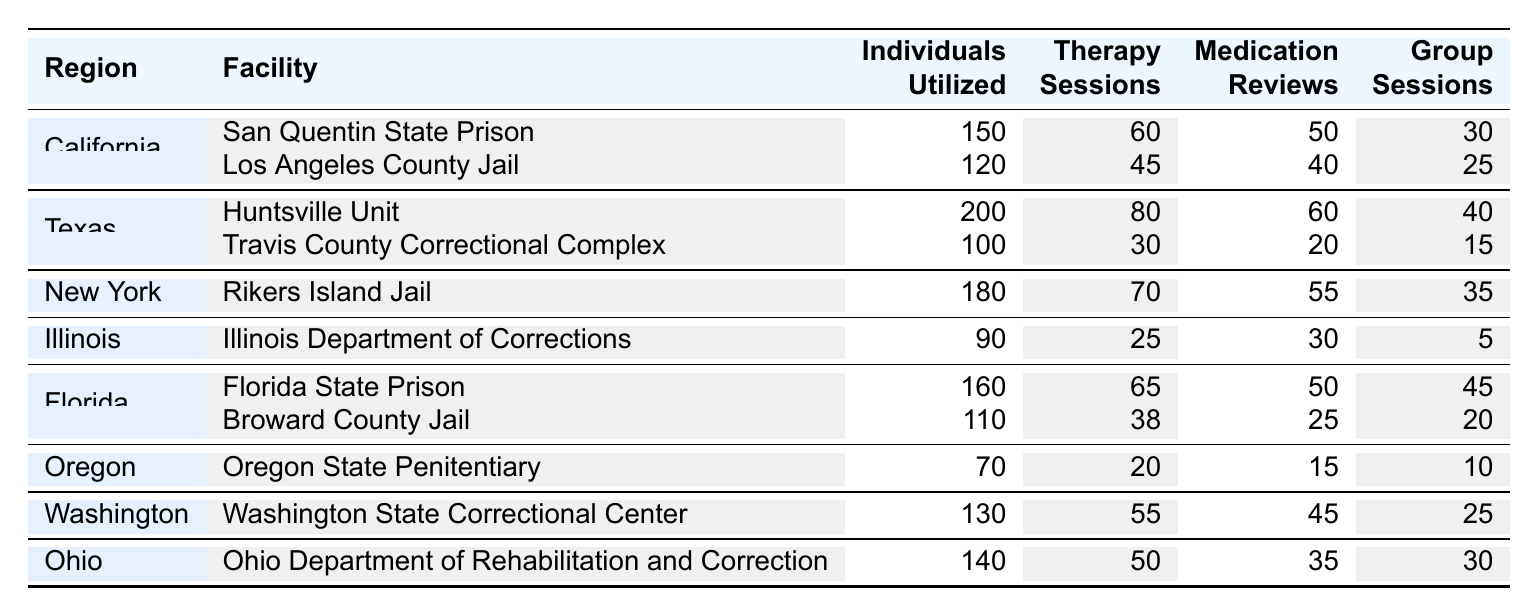What is the total number of individuals utilizing mental health services in Florida prisons for January? In Florida, two facilities reported the number of individuals utilizing services: Florida State Prison (160) and Broward County Jail (110). Adding these figures gives us 160 + 110 = 270.
Answer: 270 Which facility in Texas had the highest number of therapy sessions? Huntsville Unit recorded 80 therapy sessions, while Travis County Correctional Complex had 30. Therefore, Huntsville Unit had the highest number of therapy sessions.
Answer: Huntsville Unit What is the average number of medication reviews across all facilities in New York? Rikers Island Jail had 55 medication reviews. Since it is the only facility in New York listed, the average is the same as the total, which is 55/1 = 55.
Answer: 55 Did any facility have more than 200 individuals utilizing mental health services? The Huntsville Unit in Texas had 200 individuals utilizing services, but no facility exceeded that number, confirming that none did.
Answer: No How many more group sessions were held at Florida State Prison compared to Broward County Jail? Florida State Prison had 45 group sessions while Broward County Jail had 20. The difference can be calculated as 45 - 20 = 25.
Answer: 25 What is the total number of individuals utilizing mental health services across all facilities in California? In California, San Quentin State Prison had 150 individuals and Los Angeles County Jail had 120. Summing these gives us 150 + 120 = 270.
Answer: 270 Which facility in Illinois had the lowest number of therapy sessions, and how many were there? Illinois Department of Corrections had 25 therapy sessions, which is the only facility listed for Illinois, so it is also the lowest.
Answer: Illinois Department of Corrections, 25 What percentage of individuals utilizing mental health services at Rikers Island Jail were involved in therapy sessions? Rikers Island Jail had 180 individuals utilizing services and 70 therapy sessions. The percentage is calculated as (70/180) * 100 = 38.89%.
Answer: Approximately 38.89% Which region had the highest overall number of individuals utilizing mental health services? Summing the individuals for each region, California (270), Texas (300), New York (180), Illinois (90), Florida (270), Oregon (70), Washington (130), and Ohio (140). Texas (300) has the highest total.
Answer: Texas How many group sessions were held in total across all facilities in the table? Adding all group sessions: 30 (San Quentin) + 25 (Los Angeles) + 40 (Huntsville) + 15 (Travis) + 35 (Rikers) + 5 (Illinois) + 45 (Florida State) + 20 (Broward) + 10 (Oregon) + 25 (Washington) + 30 (Ohio) gives a total of 300.
Answer: 300 